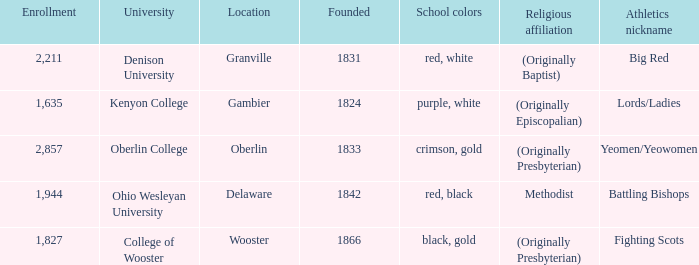What was the religious affiliation for the athletics nicknamed lords/ladies? (Originally Episcopalian). 